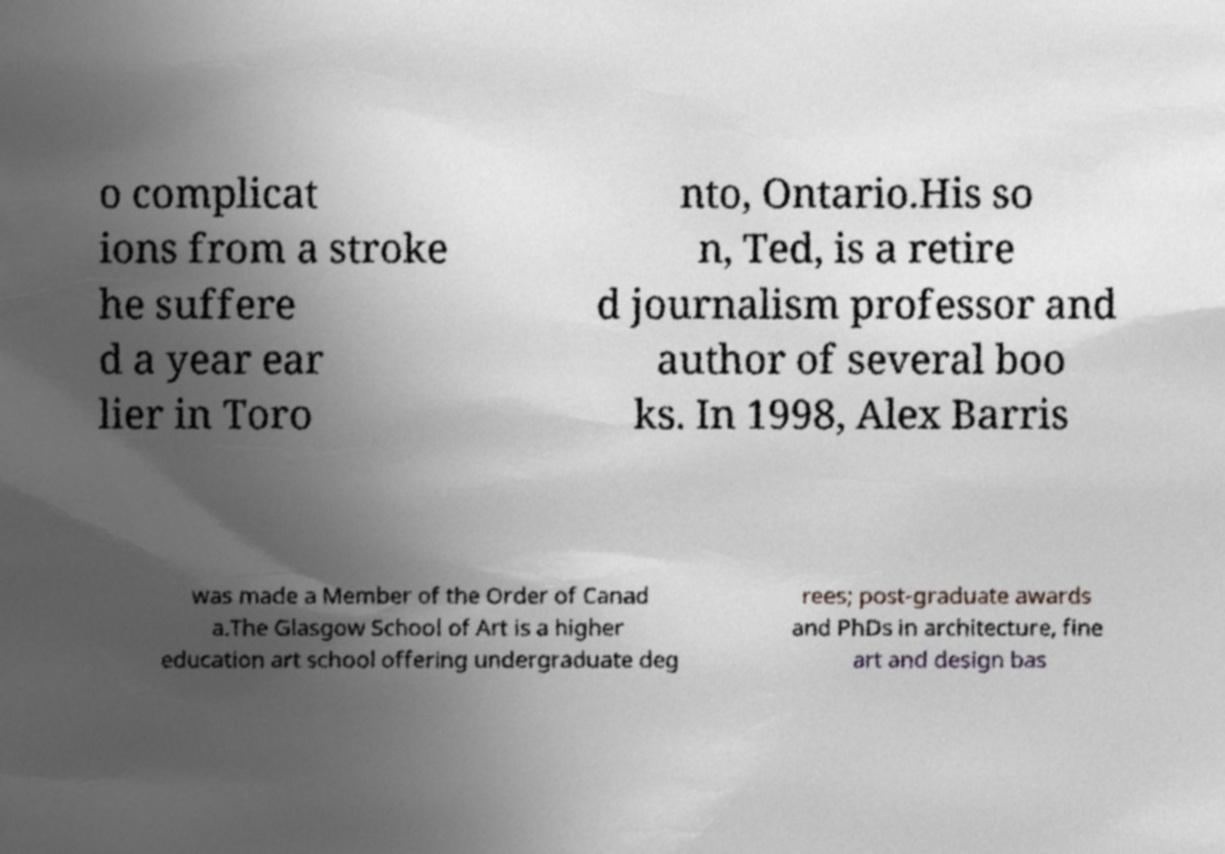Can you read and provide the text displayed in the image?This photo seems to have some interesting text. Can you extract and type it out for me? o complicat ions from a stroke he suffere d a year ear lier in Toro nto, Ontario.His so n, Ted, is a retire d journalism professor and author of several boo ks. In 1998, Alex Barris was made a Member of the Order of Canad a.The Glasgow School of Art is a higher education art school offering undergraduate deg rees; post-graduate awards and PhDs in architecture, fine art and design bas 